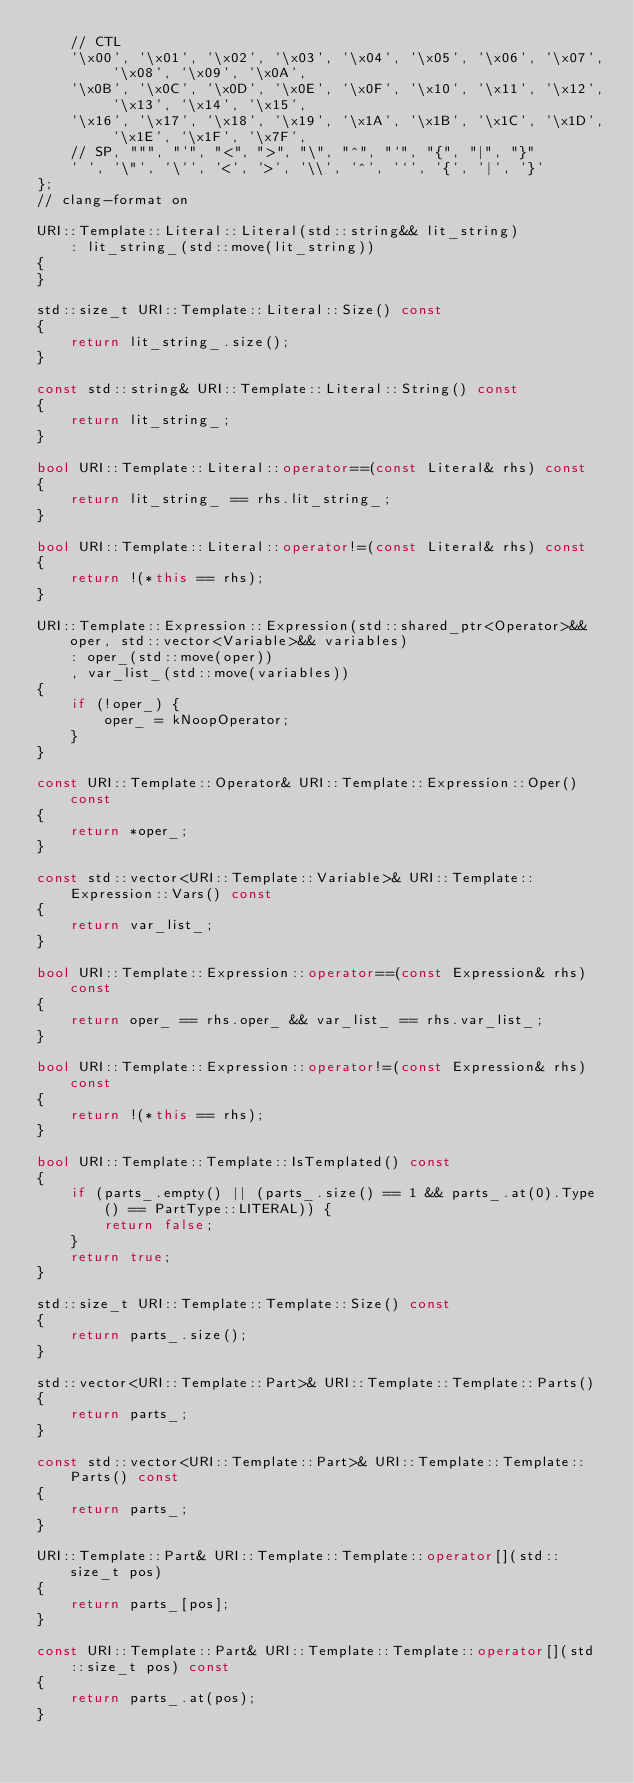<code> <loc_0><loc_0><loc_500><loc_500><_C++_>    // CTL
    '\x00', '\x01', '\x02', '\x03', '\x04', '\x05', '\x06', '\x07', '\x08', '\x09', '\x0A',
    '\x0B', '\x0C', '\x0D', '\x0E', '\x0F', '\x10', '\x11', '\x12', '\x13', '\x14', '\x15',
    '\x16', '\x17', '\x18', '\x19', '\x1A', '\x1B', '\x1C', '\x1D', '\x1E', '\x1F', '\x7F',
    // SP, """, "'", "<", ">", "\", "^", "`", "{", "|", "}"
    ' ', '\"', '\'', '<', '>', '\\', '^', '`', '{', '|', '}'
};
// clang-format on

URI::Template::Literal::Literal(std::string&& lit_string)
    : lit_string_(std::move(lit_string))
{
}

std::size_t URI::Template::Literal::Size() const
{
    return lit_string_.size();
}

const std::string& URI::Template::Literal::String() const
{
    return lit_string_;
}

bool URI::Template::Literal::operator==(const Literal& rhs) const
{
    return lit_string_ == rhs.lit_string_;
}

bool URI::Template::Literal::operator!=(const Literal& rhs) const
{
    return !(*this == rhs);
}

URI::Template::Expression::Expression(std::shared_ptr<Operator>&& oper, std::vector<Variable>&& variables)
    : oper_(std::move(oper))
    , var_list_(std::move(variables))
{
    if (!oper_) {
        oper_ = kNoopOperator;
    }
}

const URI::Template::Operator& URI::Template::Expression::Oper() const
{
    return *oper_;
}

const std::vector<URI::Template::Variable>& URI::Template::Expression::Vars() const
{
    return var_list_;
}

bool URI::Template::Expression::operator==(const Expression& rhs) const
{
    return oper_ == rhs.oper_ && var_list_ == rhs.var_list_;
}

bool URI::Template::Expression::operator!=(const Expression& rhs) const
{
    return !(*this == rhs);
}

bool URI::Template::Template::IsTemplated() const
{
    if (parts_.empty() || (parts_.size() == 1 && parts_.at(0).Type() == PartType::LITERAL)) {
        return false;
    }
    return true;
}

std::size_t URI::Template::Template::Size() const
{
    return parts_.size();
}

std::vector<URI::Template::Part>& URI::Template::Template::Parts()
{
    return parts_;
}

const std::vector<URI::Template::Part>& URI::Template::Template::Parts() const
{
    return parts_;
}

URI::Template::Part& URI::Template::Template::operator[](std::size_t pos)
{
    return parts_[pos];
}

const URI::Template::Part& URI::Template::Template::operator[](std::size_t pos) const
{
    return parts_.at(pos);
}
</code> 